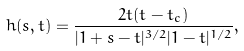<formula> <loc_0><loc_0><loc_500><loc_500>h ( s , t ) = \frac { 2 t ( t - t _ { c } ) } { | 1 + s - t | ^ { 3 / 2 } | 1 - t | ^ { 1 / 2 } } ,</formula> 